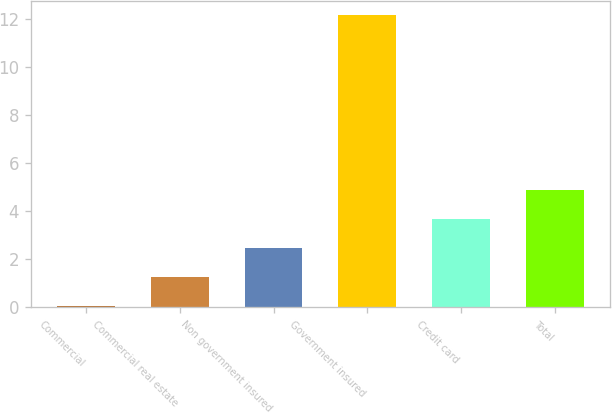Convert chart to OTSL. <chart><loc_0><loc_0><loc_500><loc_500><bar_chart><fcel>Commercial<fcel>Commercial real estate<fcel>Non government insured<fcel>Government insured<fcel>Credit card<fcel>Total<nl><fcel>0.05<fcel>1.26<fcel>2.47<fcel>12.17<fcel>3.68<fcel>4.89<nl></chart> 